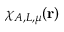<formula> <loc_0><loc_0><loc_500><loc_500>\chi _ { A , L , \mu } ( r )</formula> 